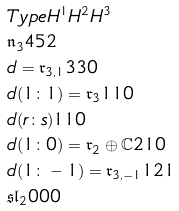<formula> <loc_0><loc_0><loc_500><loc_500>& T y p e H ^ { 1 } H ^ { 2 } H ^ { 3 } \\ & \mathfrak { n } _ { 3 } 4 5 2 \\ & d = \mathfrak { r } _ { 3 , 1 } 3 3 0 \\ & d ( 1 \colon 1 ) = \mathfrak { r } _ { 3 } 1 1 0 \\ & d ( r \colon s ) 1 1 0 \\ & d ( 1 \colon 0 ) = \mathfrak { r } _ { 2 } \oplus \mathbb { C } 2 1 0 \\ & d ( 1 \colon - 1 ) = \mathfrak { r } _ { 3 , - 1 } 1 2 1 \\ & \mathfrak { s l } _ { 2 } 0 0 0</formula> 